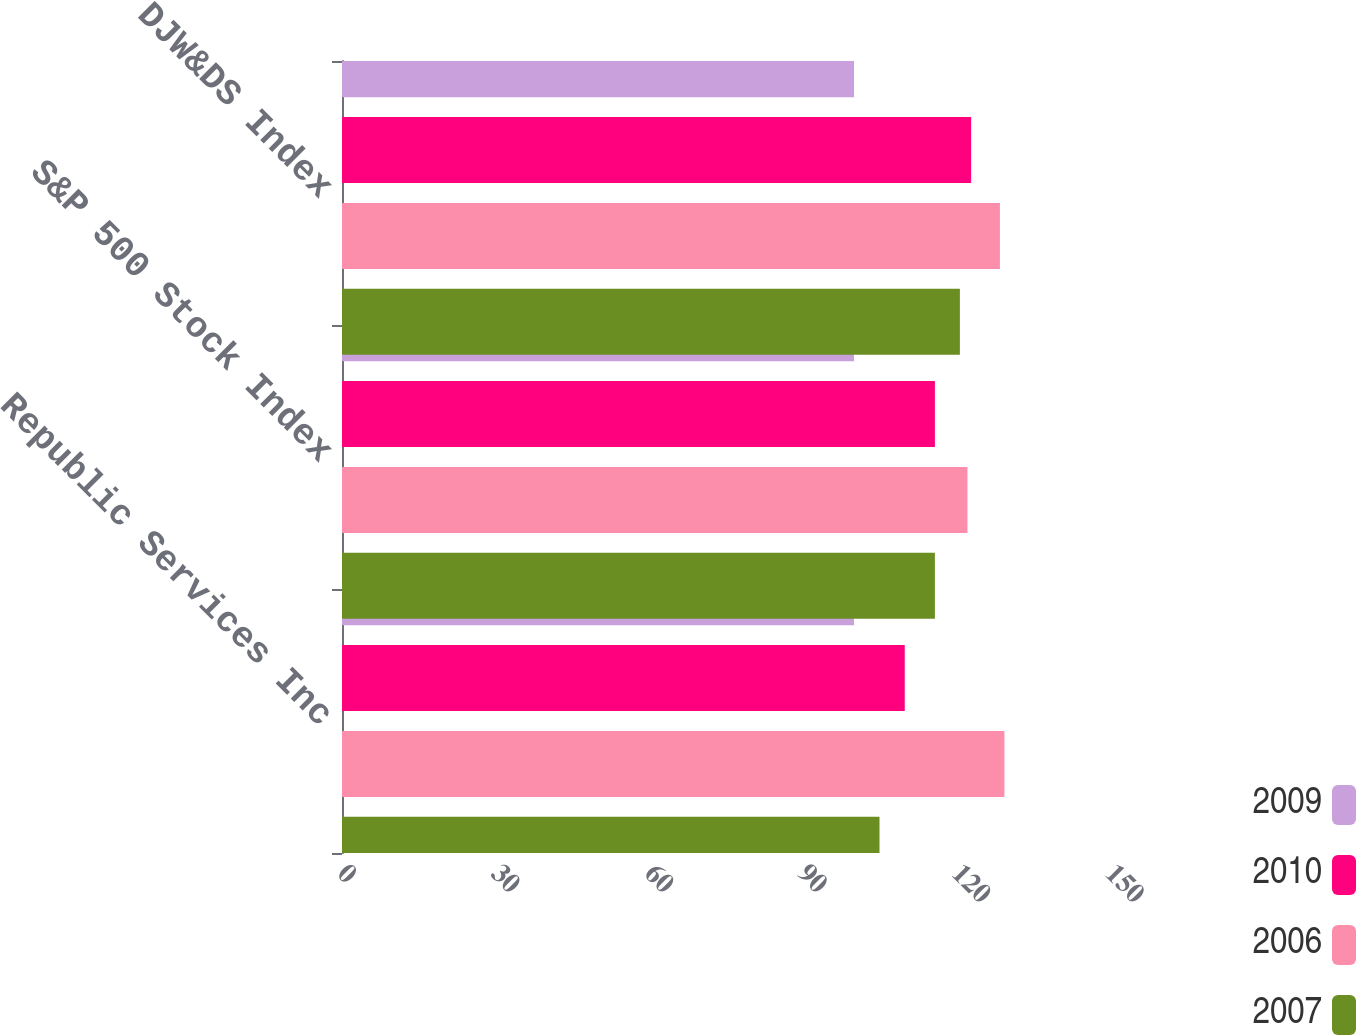<chart> <loc_0><loc_0><loc_500><loc_500><stacked_bar_chart><ecel><fcel>Republic Services Inc<fcel>S&P 500 Stock Index<fcel>DJW&DS Index<nl><fcel>2009<fcel>100<fcel>100<fcel>100<nl><fcel>2010<fcel>109.91<fcel>115.8<fcel>122.88<nl><fcel>2006<fcel>129.38<fcel>122.16<fcel>128.5<nl><fcel>2007<fcel>104.98<fcel>115.8<fcel>120.68<nl></chart> 